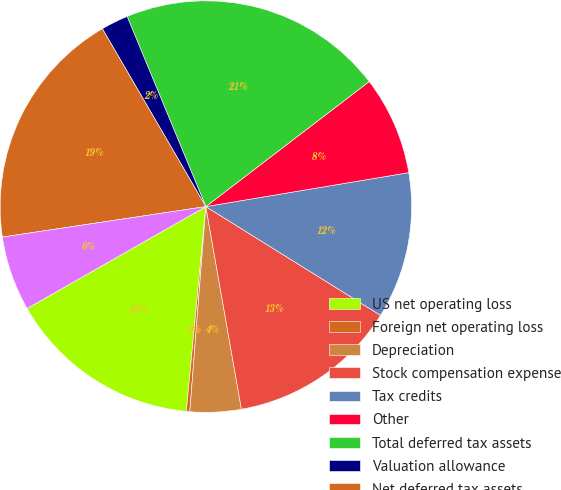Convert chart. <chart><loc_0><loc_0><loc_500><loc_500><pie_chart><fcel>US net operating loss<fcel>Foreign net operating loss<fcel>Depreciation<fcel>Stock compensation expense<fcel>Tax credits<fcel>Other<fcel>Total deferred tax assets<fcel>Valuation allowance<fcel>Net deferred tax assets<fcel>Capitalized software<nl><fcel>15.24%<fcel>0.27%<fcel>4.01%<fcel>13.37%<fcel>11.5%<fcel>7.76%<fcel>20.85%<fcel>2.14%<fcel>18.98%<fcel>5.88%<nl></chart> 